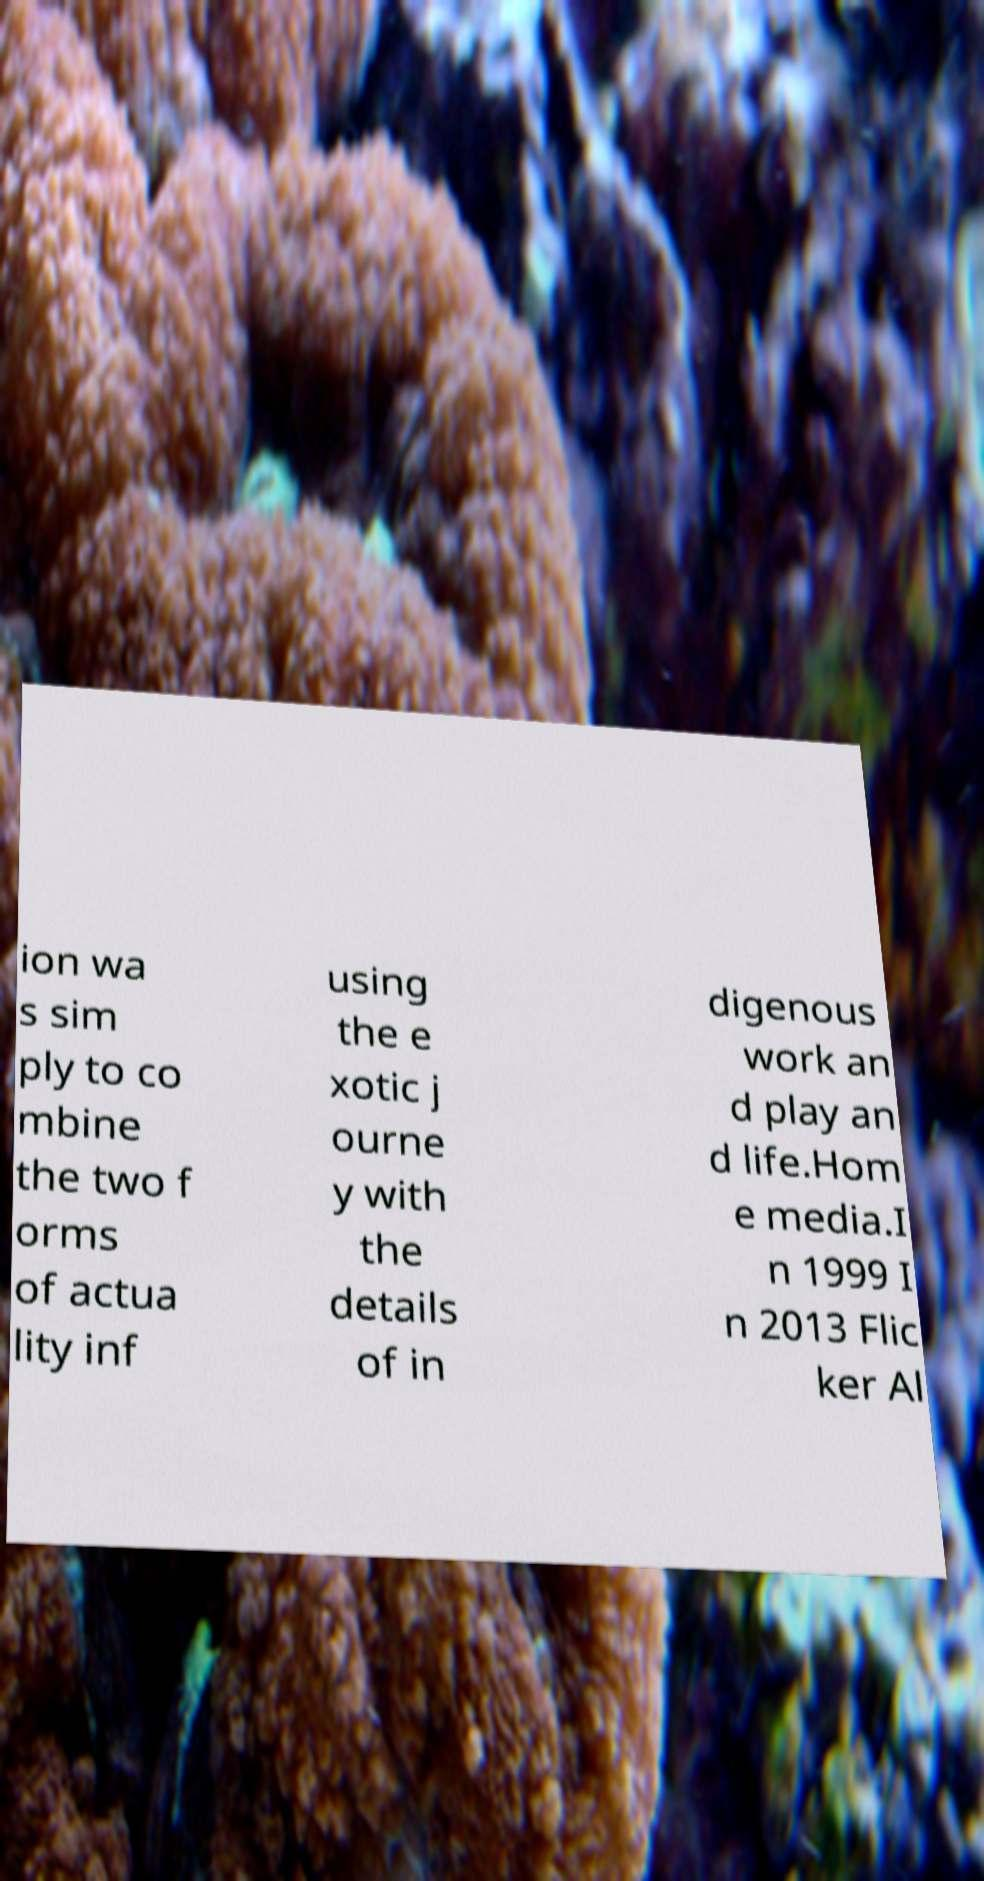For documentation purposes, I need the text within this image transcribed. Could you provide that? ion wa s sim ply to co mbine the two f orms of actua lity inf using the e xotic j ourne y with the details of in digenous work an d play an d life.Hom e media.I n 1999 I n 2013 Flic ker Al 